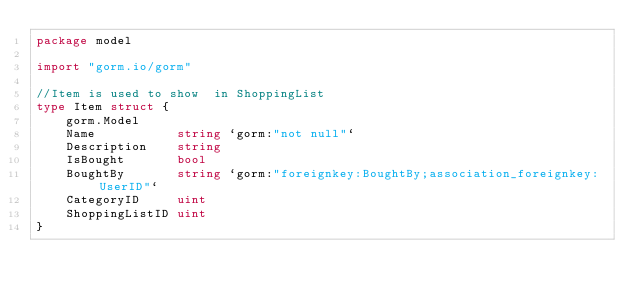<code> <loc_0><loc_0><loc_500><loc_500><_Go_>package model

import "gorm.io/gorm"

//Item is used to show  in ShoppingList
type Item struct {
	gorm.Model
	Name           string `gorm:"not null"`
	Description    string
	IsBought       bool
	BoughtBy       string `gorm:"foreignkey:BoughtBy;association_foreignkey:UserID"`
	CategoryID     uint
	ShoppingListID uint
}
</code> 